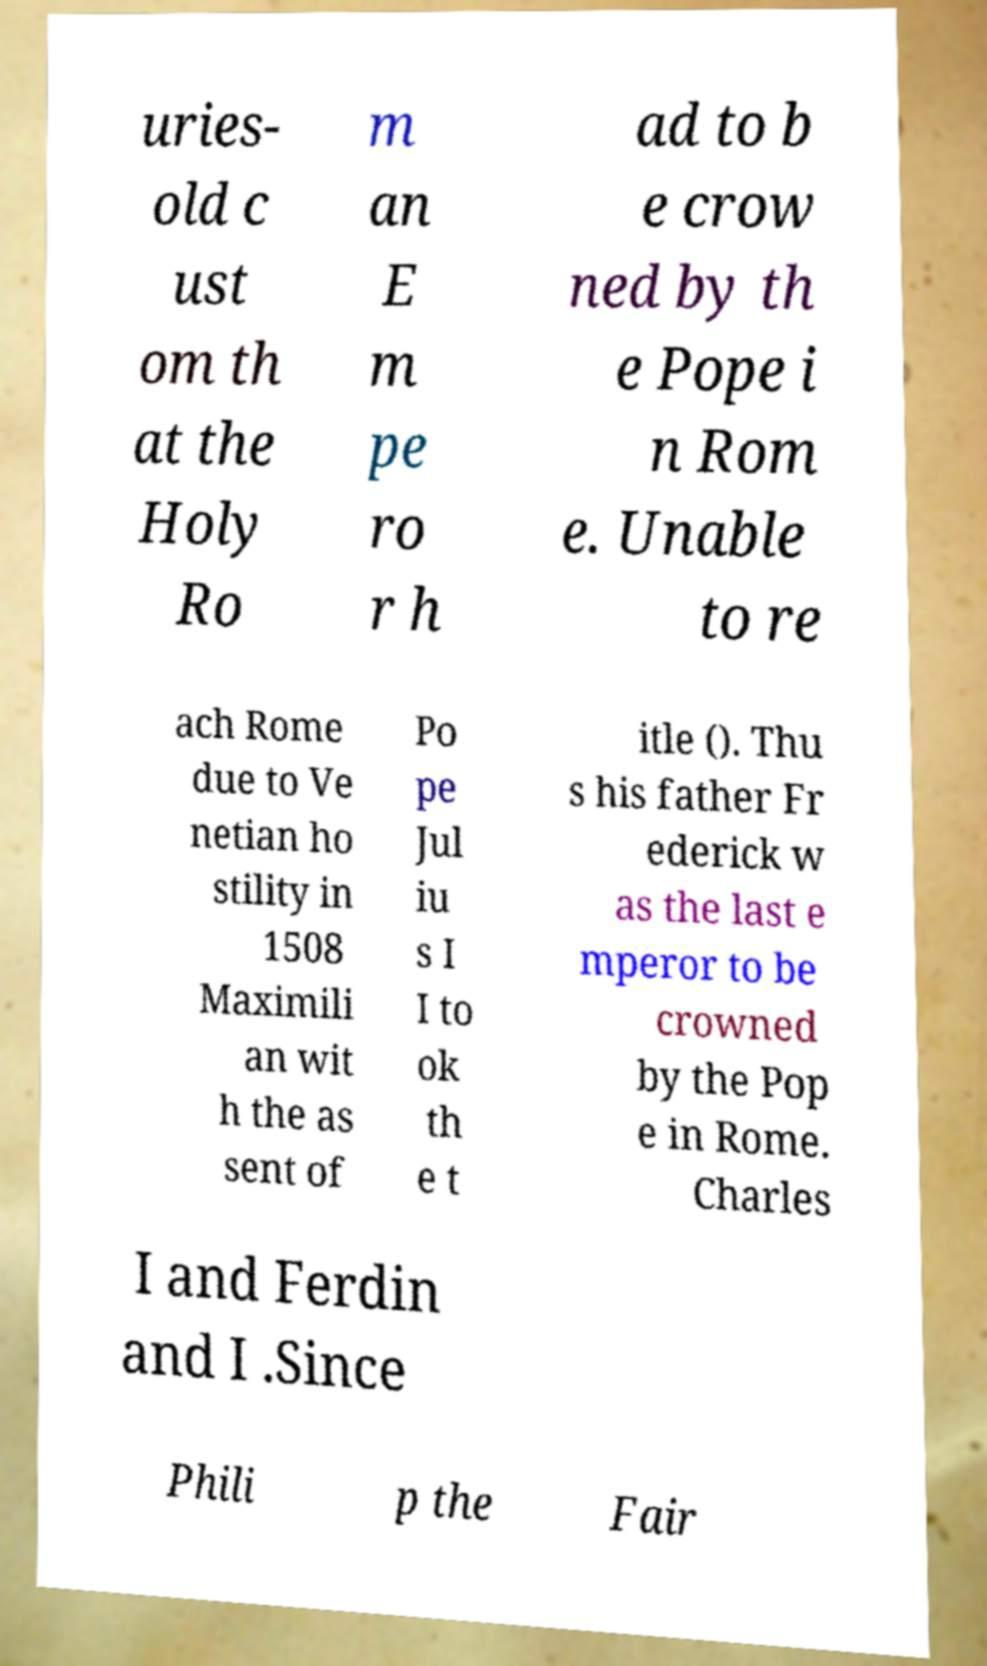There's text embedded in this image that I need extracted. Can you transcribe it verbatim? uries- old c ust om th at the Holy Ro m an E m pe ro r h ad to b e crow ned by th e Pope i n Rom e. Unable to re ach Rome due to Ve netian ho stility in 1508 Maximili an wit h the as sent of Po pe Jul iu s I I to ok th e t itle (). Thu s his father Fr ederick w as the last e mperor to be crowned by the Pop e in Rome. Charles I and Ferdin and I .Since Phili p the Fair 